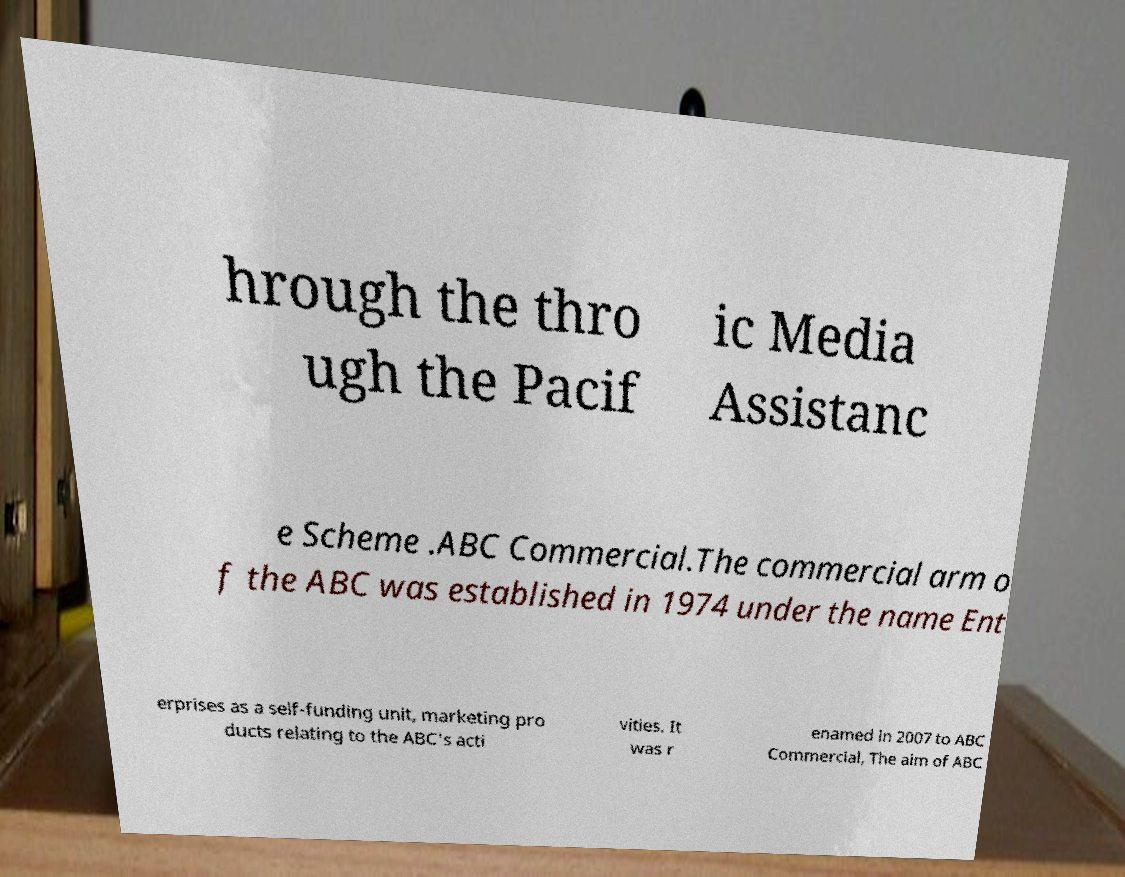Please read and relay the text visible in this image. What does it say? hrough the thro ugh the Pacif ic Media Assistanc e Scheme .ABC Commercial.The commercial arm o f the ABC was established in 1974 under the name Ent erprises as a self-funding unit, marketing pro ducts relating to the ABC's acti vities. It was r enamed in 2007 to ABC Commercial, The aim of ABC 